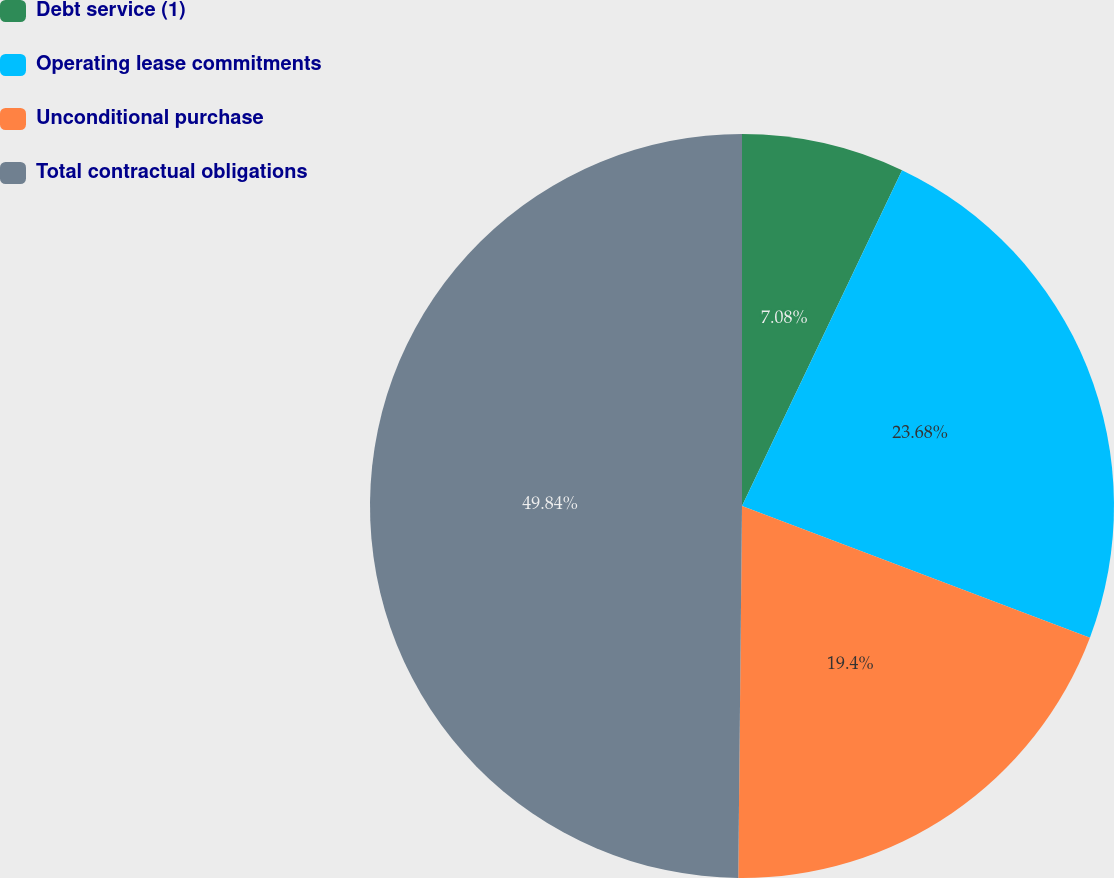Convert chart to OTSL. <chart><loc_0><loc_0><loc_500><loc_500><pie_chart><fcel>Debt service (1)<fcel>Operating lease commitments<fcel>Unconditional purchase<fcel>Total contractual obligations<nl><fcel>7.08%<fcel>23.68%<fcel>19.4%<fcel>49.84%<nl></chart> 